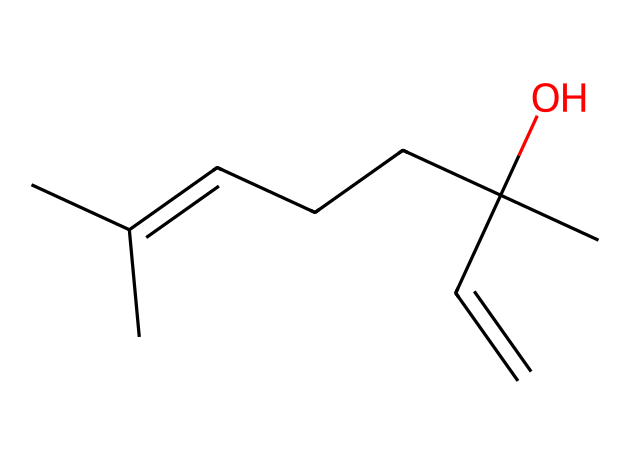What is the main functional group present in linalool? The SMILES representation indicates the presence of an alcohol group (-OH), which is identified by the oxygen atom bonded to a carbon and a hydrogen. This characteristic defines the functional group.
Answer: alcohol How many carbon atoms are in the structure of linalool? By analyzing the provided SMILES, we can count the number of 'C' symbols, which represent carbon atoms. There are 10 carbon atoms in total present in the chemical structure.
Answer: 10 What type of compound is linalool classified as? The structure of linalool features multiple carbon atoms and a distinct arrangement of double bonds and functional groups, which categorizes it as a terpene.
Answer: terpene How many double bonds are present in linalool? Examining the structure reveals two locations where double bonds are formed between carbon atoms, identifiable through the absence of hydrogen atoms connected to the double-bonded carbon.
Answer: 2 Does linalool have a chiral center? A chiral center is defined by a carbon atom bonded to four different groups. In linalool, one carbon atom is connected to an -OH group, a propyl group, and two other similar groups, making it asymmetrical. Hence, there is a chiral center.
Answer: yes What is the primary use of linalool in consumer products? Linalool is commonly utilized for its fragrance and stress-reducing properties in aromatherapy products and cosmetics, which capitalizes on its soothing scent.
Answer: aromatherapy 